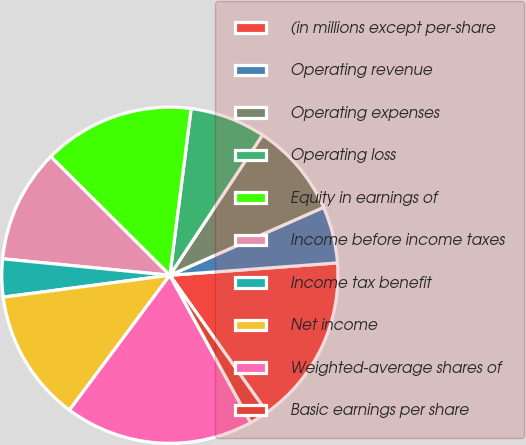Convert chart to OTSL. <chart><loc_0><loc_0><loc_500><loc_500><pie_chart><fcel>(in millions except per-share<fcel>Operating revenue<fcel>Operating expenses<fcel>Operating loss<fcel>Equity in earnings of<fcel>Income before income taxes<fcel>Income tax benefit<fcel>Net income<fcel>Weighted-average shares of<fcel>Basic earnings per share<nl><fcel>16.36%<fcel>5.45%<fcel>9.09%<fcel>7.27%<fcel>14.55%<fcel>10.91%<fcel>3.64%<fcel>12.73%<fcel>18.18%<fcel>1.82%<nl></chart> 